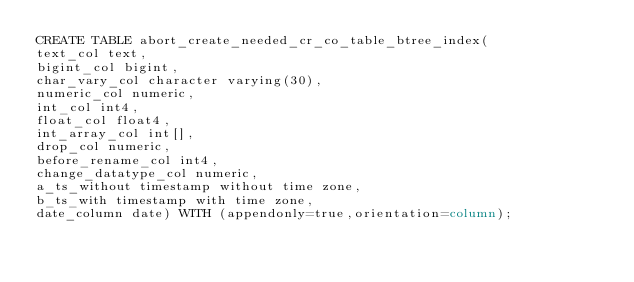Convert code to text. <code><loc_0><loc_0><loc_500><loc_500><_SQL_>CREATE TABLE abort_create_needed_cr_co_table_btree_index(
text_col text,
bigint_col bigint,
char_vary_col character varying(30),
numeric_col numeric,
int_col int4,
float_col float4,
int_array_col int[],
drop_col numeric,
before_rename_col int4,
change_datatype_col numeric,
a_ts_without timestamp without time zone,
b_ts_with timestamp with time zone,
date_column date) WITH (appendonly=true,orientation=column);
</code> 